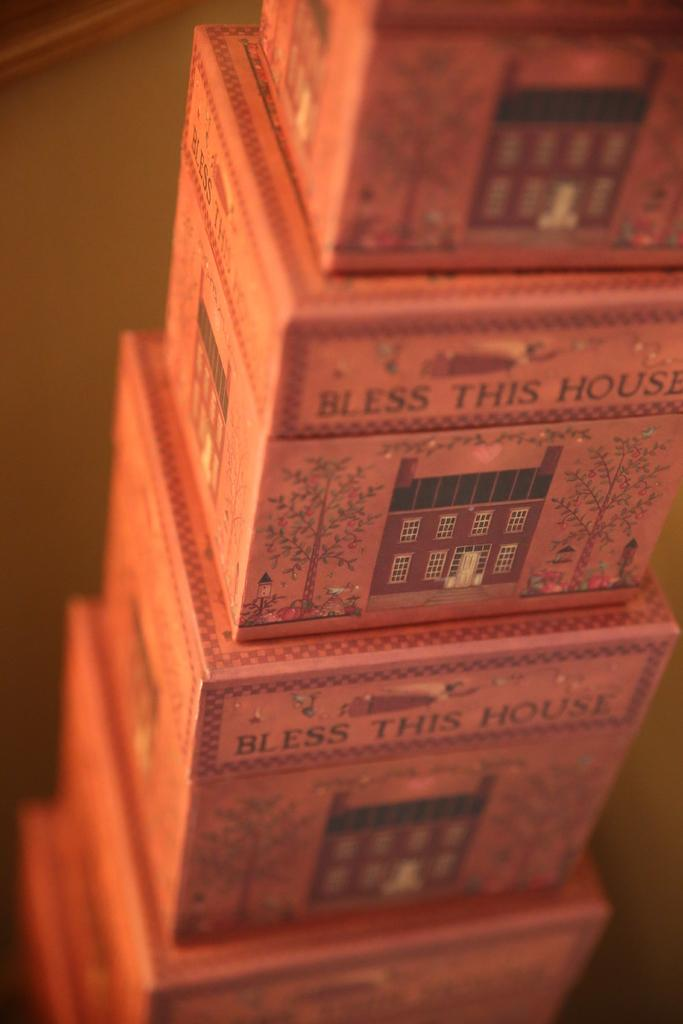<image>
Describe the image concisely. Stacked boxes of decreasing size are all labeled Bless This House. 